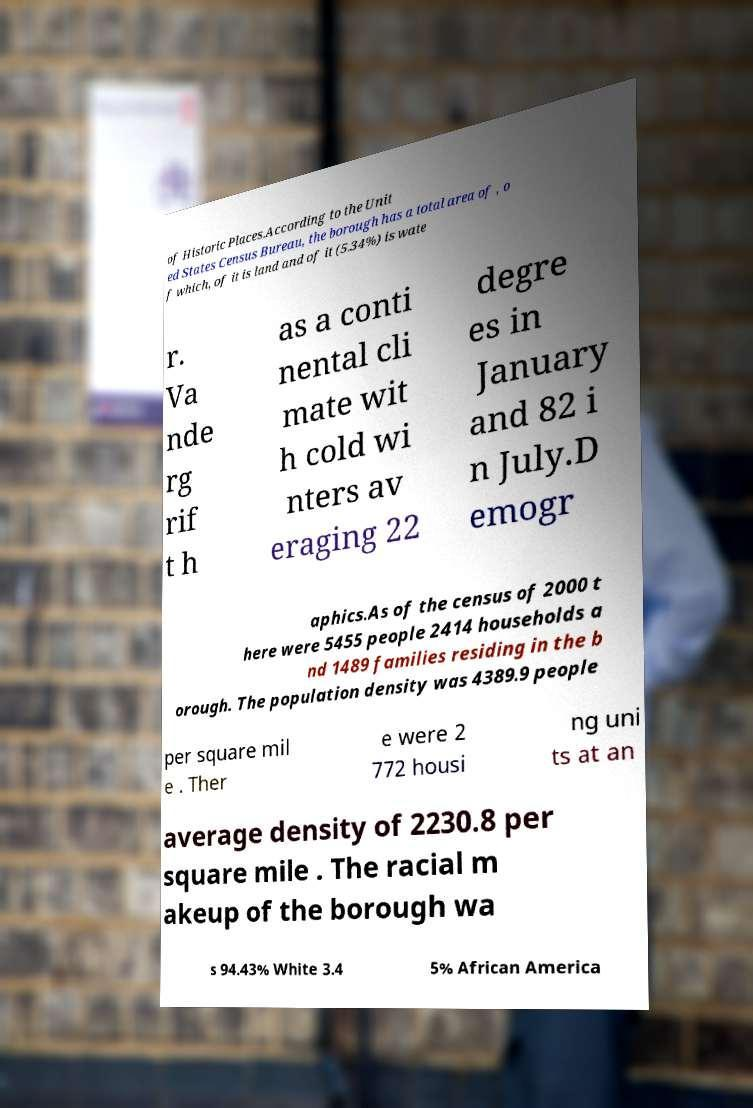Please read and relay the text visible in this image. What does it say? of Historic Places.According to the Unit ed States Census Bureau, the borough has a total area of , o f which, of it is land and of it (5.34%) is wate r. Va nde rg rif t h as a conti nental cli mate wit h cold wi nters av eraging 22 degre es in January and 82 i n July.D emogr aphics.As of the census of 2000 t here were 5455 people 2414 households a nd 1489 families residing in the b orough. The population density was 4389.9 people per square mil e . Ther e were 2 772 housi ng uni ts at an average density of 2230.8 per square mile . The racial m akeup of the borough wa s 94.43% White 3.4 5% African America 